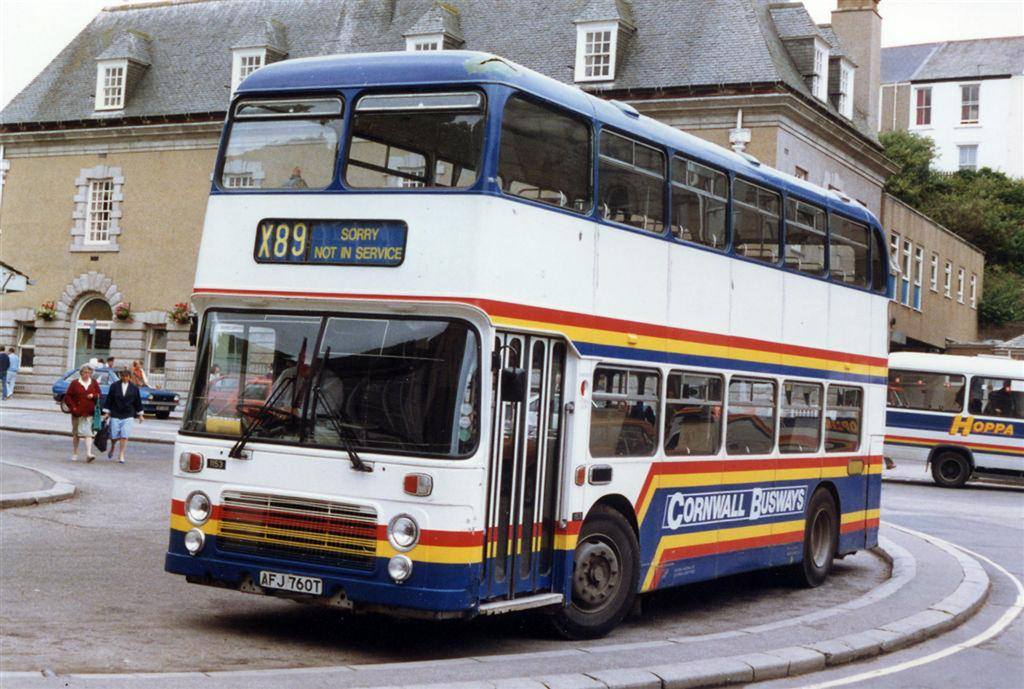What can be seen on the road in the image? There are vehicles and people on the road in the image. What type of structures can be seen in the image? There are buildings visible in the image. What natural elements are present in the image? Trees are present in the image. What architectural features can be seen in the image? Windows are visible in the image. What objects are related to floral arrangements in the image? Flower bouquets are present in the image. What part of the natural environment is visible in the image? The sky is visible in the image. What type of appliance is being played by the person in the image? There is no person playing an appliance in the image; the image features vehicles, people, buildings, trees, windows, flower bouquets, and the sky. What type of guitar is being used by the person in the image? There is no person playing a guitar in the image; the image features vehicles, people, buildings, trees, windows, flower bouquets, and the sky. 